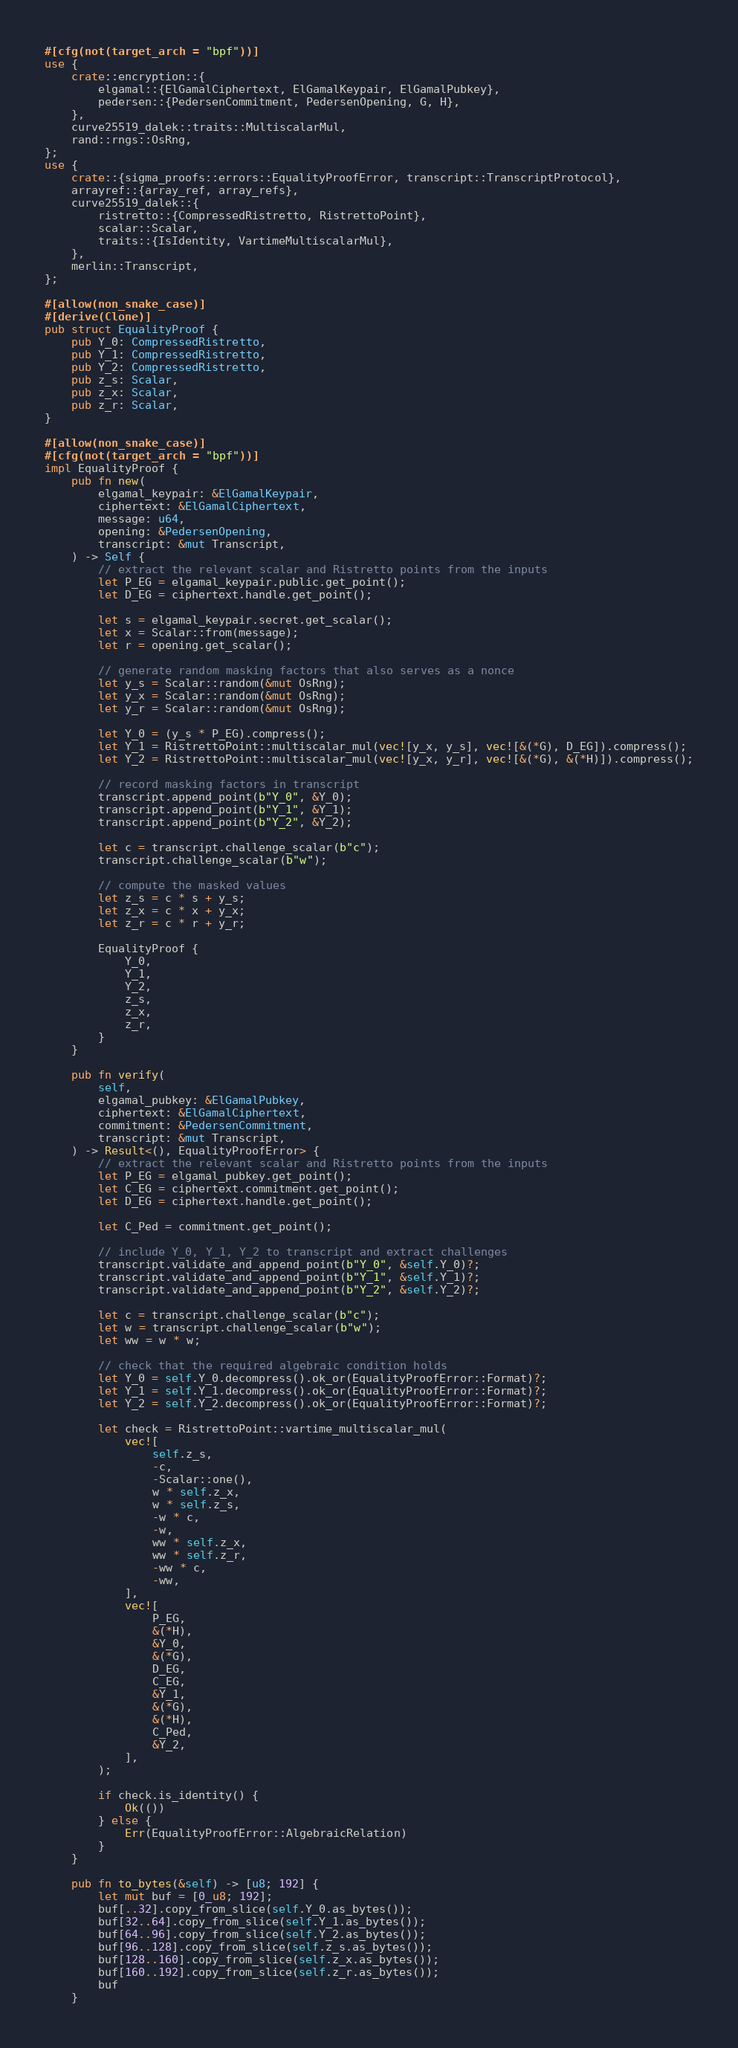<code> <loc_0><loc_0><loc_500><loc_500><_Rust_>#[cfg(not(target_arch = "bpf"))]
use {
    crate::encryption::{
        elgamal::{ElGamalCiphertext, ElGamalKeypair, ElGamalPubkey},
        pedersen::{PedersenCommitment, PedersenOpening, G, H},
    },
    curve25519_dalek::traits::MultiscalarMul,
    rand::rngs::OsRng,
};
use {
    crate::{sigma_proofs::errors::EqualityProofError, transcript::TranscriptProtocol},
    arrayref::{array_ref, array_refs},
    curve25519_dalek::{
        ristretto::{CompressedRistretto, RistrettoPoint},
        scalar::Scalar,
        traits::{IsIdentity, VartimeMultiscalarMul},
    },
    merlin::Transcript,
};

#[allow(non_snake_case)]
#[derive(Clone)]
pub struct EqualityProof {
    pub Y_0: CompressedRistretto,
    pub Y_1: CompressedRistretto,
    pub Y_2: CompressedRistretto,
    pub z_s: Scalar,
    pub z_x: Scalar,
    pub z_r: Scalar,
}

#[allow(non_snake_case)]
#[cfg(not(target_arch = "bpf"))]
impl EqualityProof {
    pub fn new(
        elgamal_keypair: &ElGamalKeypair,
        ciphertext: &ElGamalCiphertext,
        message: u64,
        opening: &PedersenOpening,
        transcript: &mut Transcript,
    ) -> Self {
        // extract the relevant scalar and Ristretto points from the inputs
        let P_EG = elgamal_keypair.public.get_point();
        let D_EG = ciphertext.handle.get_point();

        let s = elgamal_keypair.secret.get_scalar();
        let x = Scalar::from(message);
        let r = opening.get_scalar();

        // generate random masking factors that also serves as a nonce
        let y_s = Scalar::random(&mut OsRng);
        let y_x = Scalar::random(&mut OsRng);
        let y_r = Scalar::random(&mut OsRng);

        let Y_0 = (y_s * P_EG).compress();
        let Y_1 = RistrettoPoint::multiscalar_mul(vec![y_x, y_s], vec![&(*G), D_EG]).compress();
        let Y_2 = RistrettoPoint::multiscalar_mul(vec![y_x, y_r], vec![&(*G), &(*H)]).compress();

        // record masking factors in transcript
        transcript.append_point(b"Y_0", &Y_0);
        transcript.append_point(b"Y_1", &Y_1);
        transcript.append_point(b"Y_2", &Y_2);

        let c = transcript.challenge_scalar(b"c");
        transcript.challenge_scalar(b"w");

        // compute the masked values
        let z_s = c * s + y_s;
        let z_x = c * x + y_x;
        let z_r = c * r + y_r;

        EqualityProof {
            Y_0,
            Y_1,
            Y_2,
            z_s,
            z_x,
            z_r,
        }
    }

    pub fn verify(
        self,
        elgamal_pubkey: &ElGamalPubkey,
        ciphertext: &ElGamalCiphertext,
        commitment: &PedersenCommitment,
        transcript: &mut Transcript,
    ) -> Result<(), EqualityProofError> {
        // extract the relevant scalar and Ristretto points from the inputs
        let P_EG = elgamal_pubkey.get_point();
        let C_EG = ciphertext.commitment.get_point();
        let D_EG = ciphertext.handle.get_point();

        let C_Ped = commitment.get_point();

        // include Y_0, Y_1, Y_2 to transcript and extract challenges
        transcript.validate_and_append_point(b"Y_0", &self.Y_0)?;
        transcript.validate_and_append_point(b"Y_1", &self.Y_1)?;
        transcript.validate_and_append_point(b"Y_2", &self.Y_2)?;

        let c = transcript.challenge_scalar(b"c");
        let w = transcript.challenge_scalar(b"w");
        let ww = w * w;

        // check that the required algebraic condition holds
        let Y_0 = self.Y_0.decompress().ok_or(EqualityProofError::Format)?;
        let Y_1 = self.Y_1.decompress().ok_or(EqualityProofError::Format)?;
        let Y_2 = self.Y_2.decompress().ok_or(EqualityProofError::Format)?;

        let check = RistrettoPoint::vartime_multiscalar_mul(
            vec![
                self.z_s,
                -c,
                -Scalar::one(),
                w * self.z_x,
                w * self.z_s,
                -w * c,
                -w,
                ww * self.z_x,
                ww * self.z_r,
                -ww * c,
                -ww,
            ],
            vec![
                P_EG,
                &(*H),
                &Y_0,
                &(*G),
                D_EG,
                C_EG,
                &Y_1,
                &(*G),
                &(*H),
                C_Ped,
                &Y_2,
            ],
        );

        if check.is_identity() {
            Ok(())
        } else {
            Err(EqualityProofError::AlgebraicRelation)
        }
    }

    pub fn to_bytes(&self) -> [u8; 192] {
        let mut buf = [0_u8; 192];
        buf[..32].copy_from_slice(self.Y_0.as_bytes());
        buf[32..64].copy_from_slice(self.Y_1.as_bytes());
        buf[64..96].copy_from_slice(self.Y_2.as_bytes());
        buf[96..128].copy_from_slice(self.z_s.as_bytes());
        buf[128..160].copy_from_slice(self.z_x.as_bytes());
        buf[160..192].copy_from_slice(self.z_r.as_bytes());
        buf
    }
</code> 